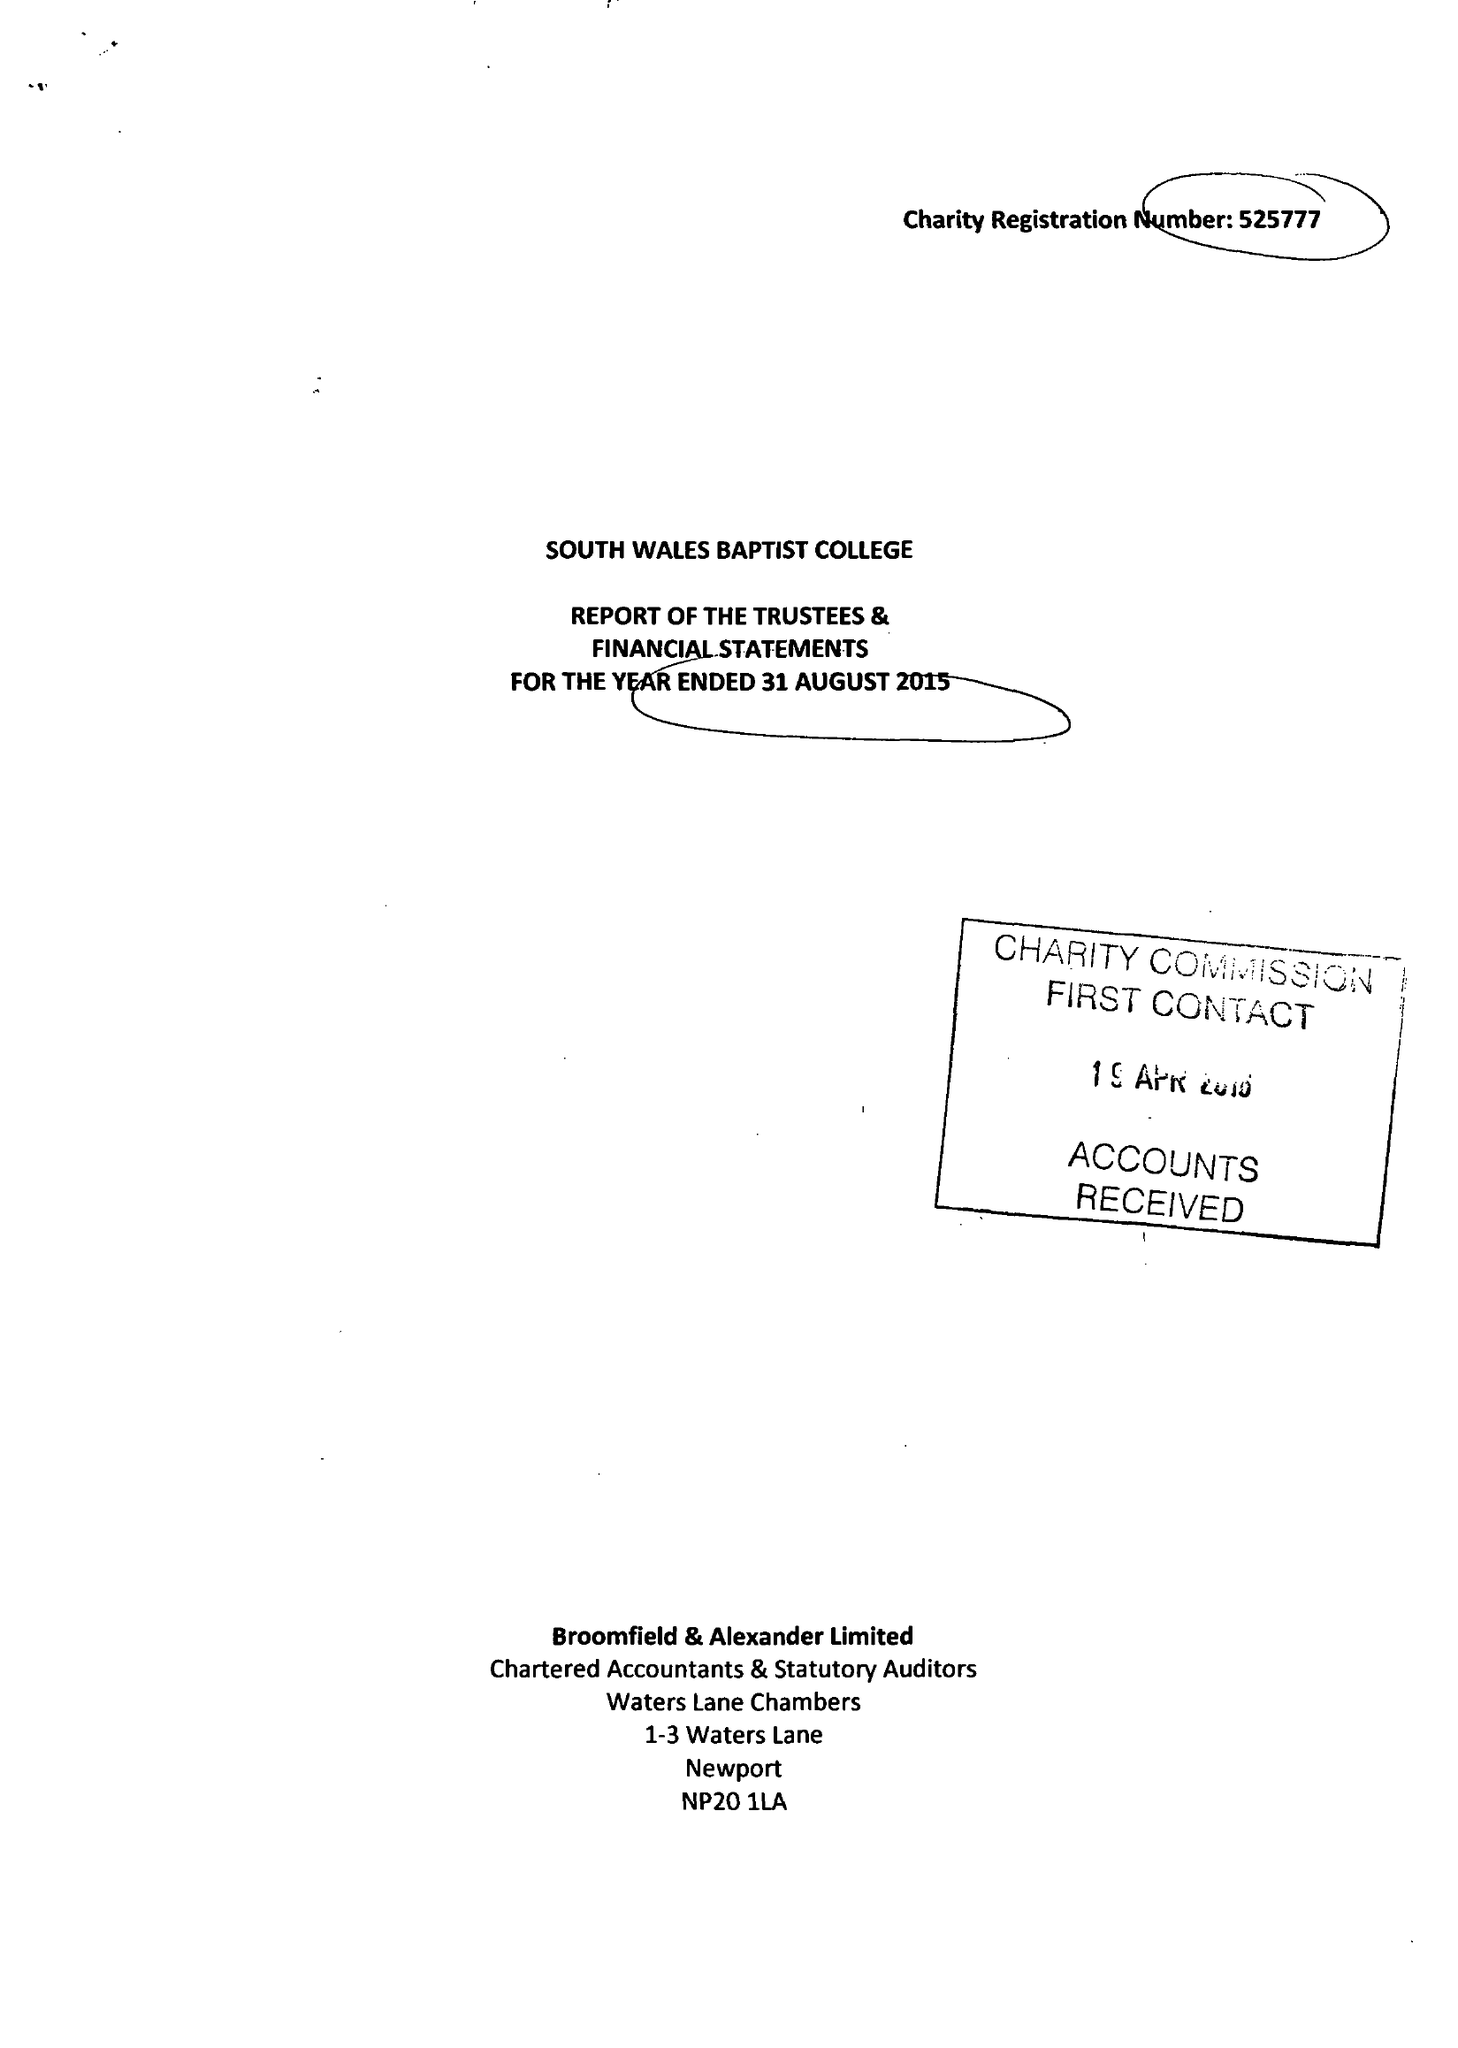What is the value for the address__street_line?
Answer the question using a single word or phrase. 54 RICHMOND ROAD 